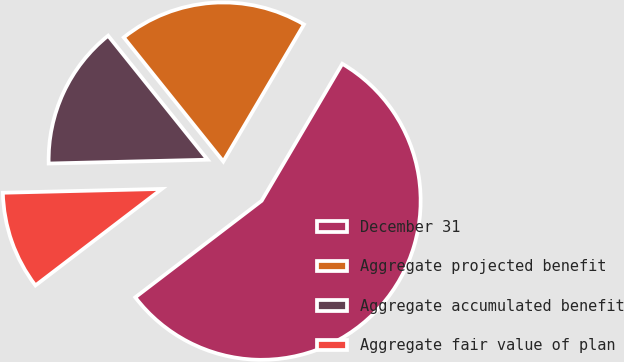Convert chart. <chart><loc_0><loc_0><loc_500><loc_500><pie_chart><fcel>December 31<fcel>Aggregate projected benefit<fcel>Aggregate accumulated benefit<fcel>Aggregate fair value of plan<nl><fcel>56.15%<fcel>19.23%<fcel>14.62%<fcel>10.0%<nl></chart> 